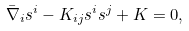<formula> <loc_0><loc_0><loc_500><loc_500>\bar { \nabla } _ { i } s ^ { i } - K _ { i j } s ^ { i } s ^ { j } + K = 0 ,</formula> 